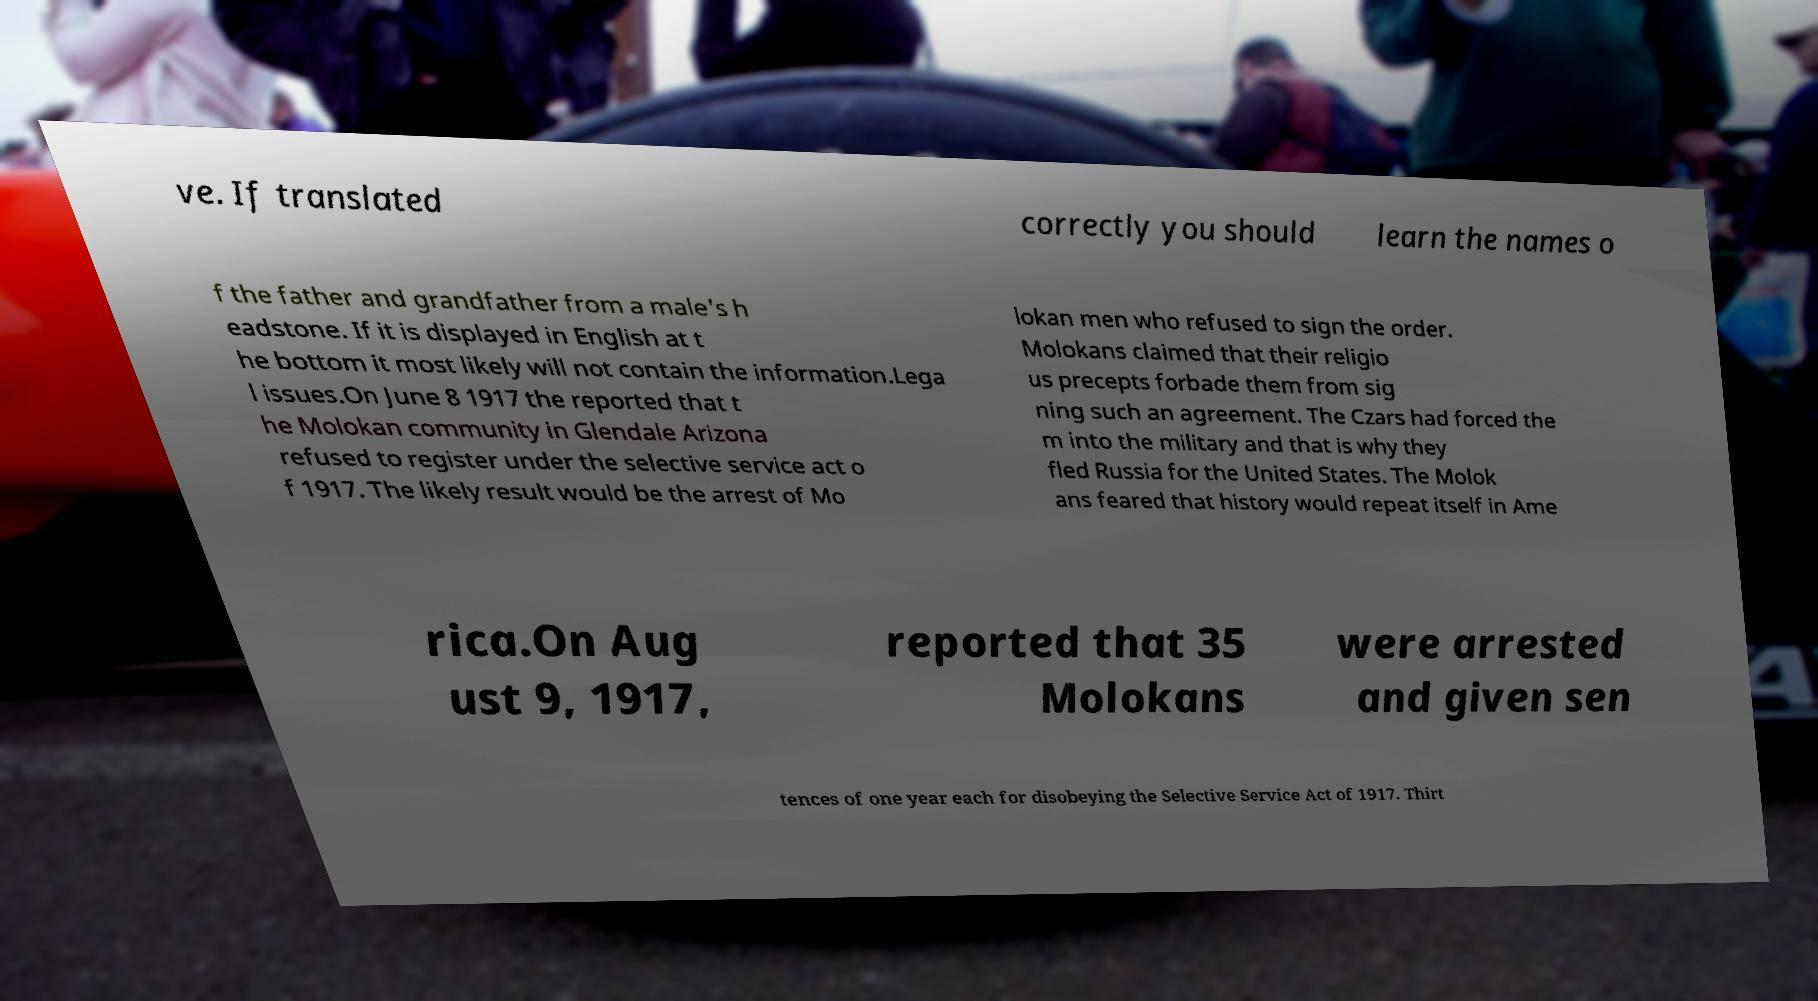For documentation purposes, I need the text within this image transcribed. Could you provide that? ve. If translated correctly you should learn the names o f the father and grandfather from a male's h eadstone. If it is displayed in English at t he bottom it most likely will not contain the information.Lega l issues.On June 8 1917 the reported that t he Molokan community in Glendale Arizona refused to register under the selective service act o f 1917. The likely result would be the arrest of Mo lokan men who refused to sign the order. Molokans claimed that their religio us precepts forbade them from sig ning such an agreement. The Czars had forced the m into the military and that is why they fled Russia for the United States. The Molok ans feared that history would repeat itself in Ame rica.On Aug ust 9, 1917, reported that 35 Molokans were arrested and given sen tences of one year each for disobeying the Selective Service Act of 1917. Thirt 